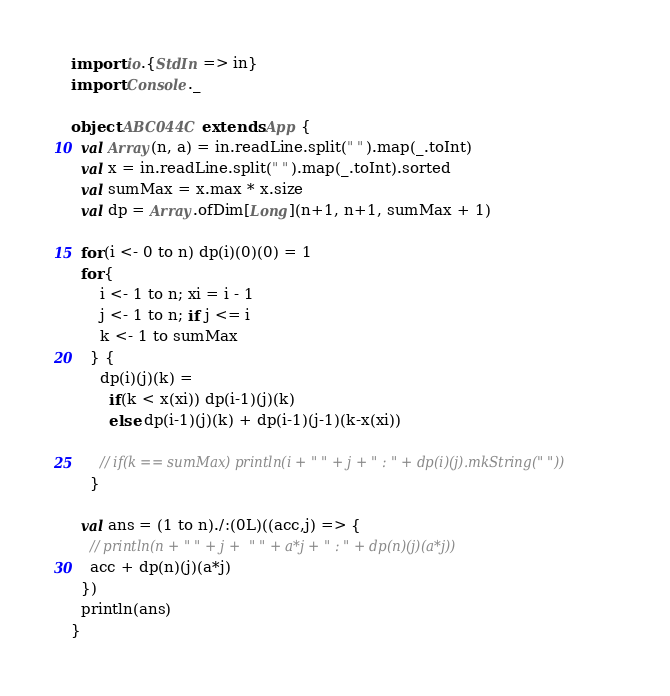Convert code to text. <code><loc_0><loc_0><loc_500><loc_500><_Scala_>import io.{StdIn => in}
import Console._

object ABC044C extends App {
  val Array(n, a) = in.readLine.split(" ").map(_.toInt)
  val x = in.readLine.split(" ").map(_.toInt).sorted
  val sumMax = x.max * x.size
  val dp = Array.ofDim[Long](n+1, n+1, sumMax + 1)

  for(i <- 0 to n) dp(i)(0)(0) = 1
  for{
      i <- 1 to n; xi = i - 1
      j <- 1 to n; if j <= i
      k <- 1 to sumMax
    } {
      dp(i)(j)(k) =
        if(k < x(xi)) dp(i-1)(j)(k)
        else dp(i-1)(j)(k) + dp(i-1)(j-1)(k-x(xi))

      // if(k == sumMax) println(i + " " + j + " : " + dp(i)(j).mkString(" "))
    }

  val ans = (1 to n)./:(0L)((acc,j) => {
    // println(n + " " + j +  " " + a*j + " : " + dp(n)(j)(a*j))
    acc + dp(n)(j)(a*j)
  })
  println(ans)
}</code> 